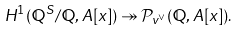Convert formula to latex. <formula><loc_0><loc_0><loc_500><loc_500>H ^ { 1 } ( \mathbb { Q } ^ { S } / \mathbb { Q } , A [ x ] ) \twoheadrightarrow \mathcal { P } _ { v ^ { \vee } } ( \mathbb { Q } , A [ x ] ) .</formula> 